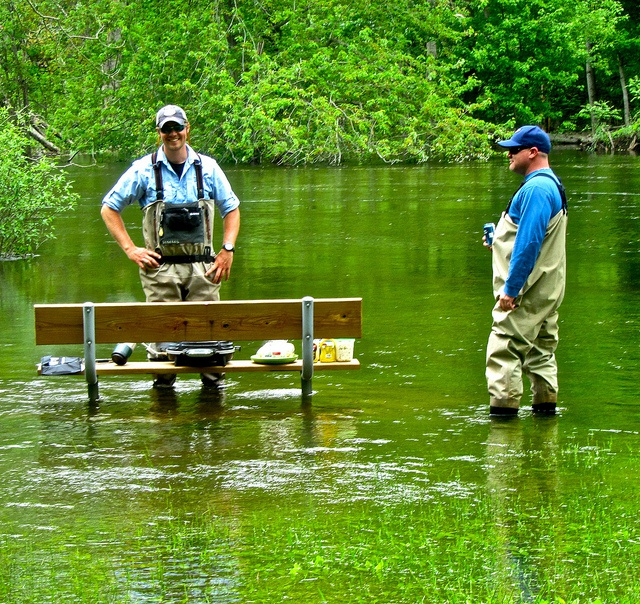Describe the objects in this image and their specific colors. I can see bench in lightgreen, olive, maroon, black, and ivory tones, people in lightgreen, darkgreen, black, and olive tones, people in lightgreen, black, darkgreen, white, and gray tones, and backpack in lightgreen, black, gray, darkgreen, and olive tones in this image. 